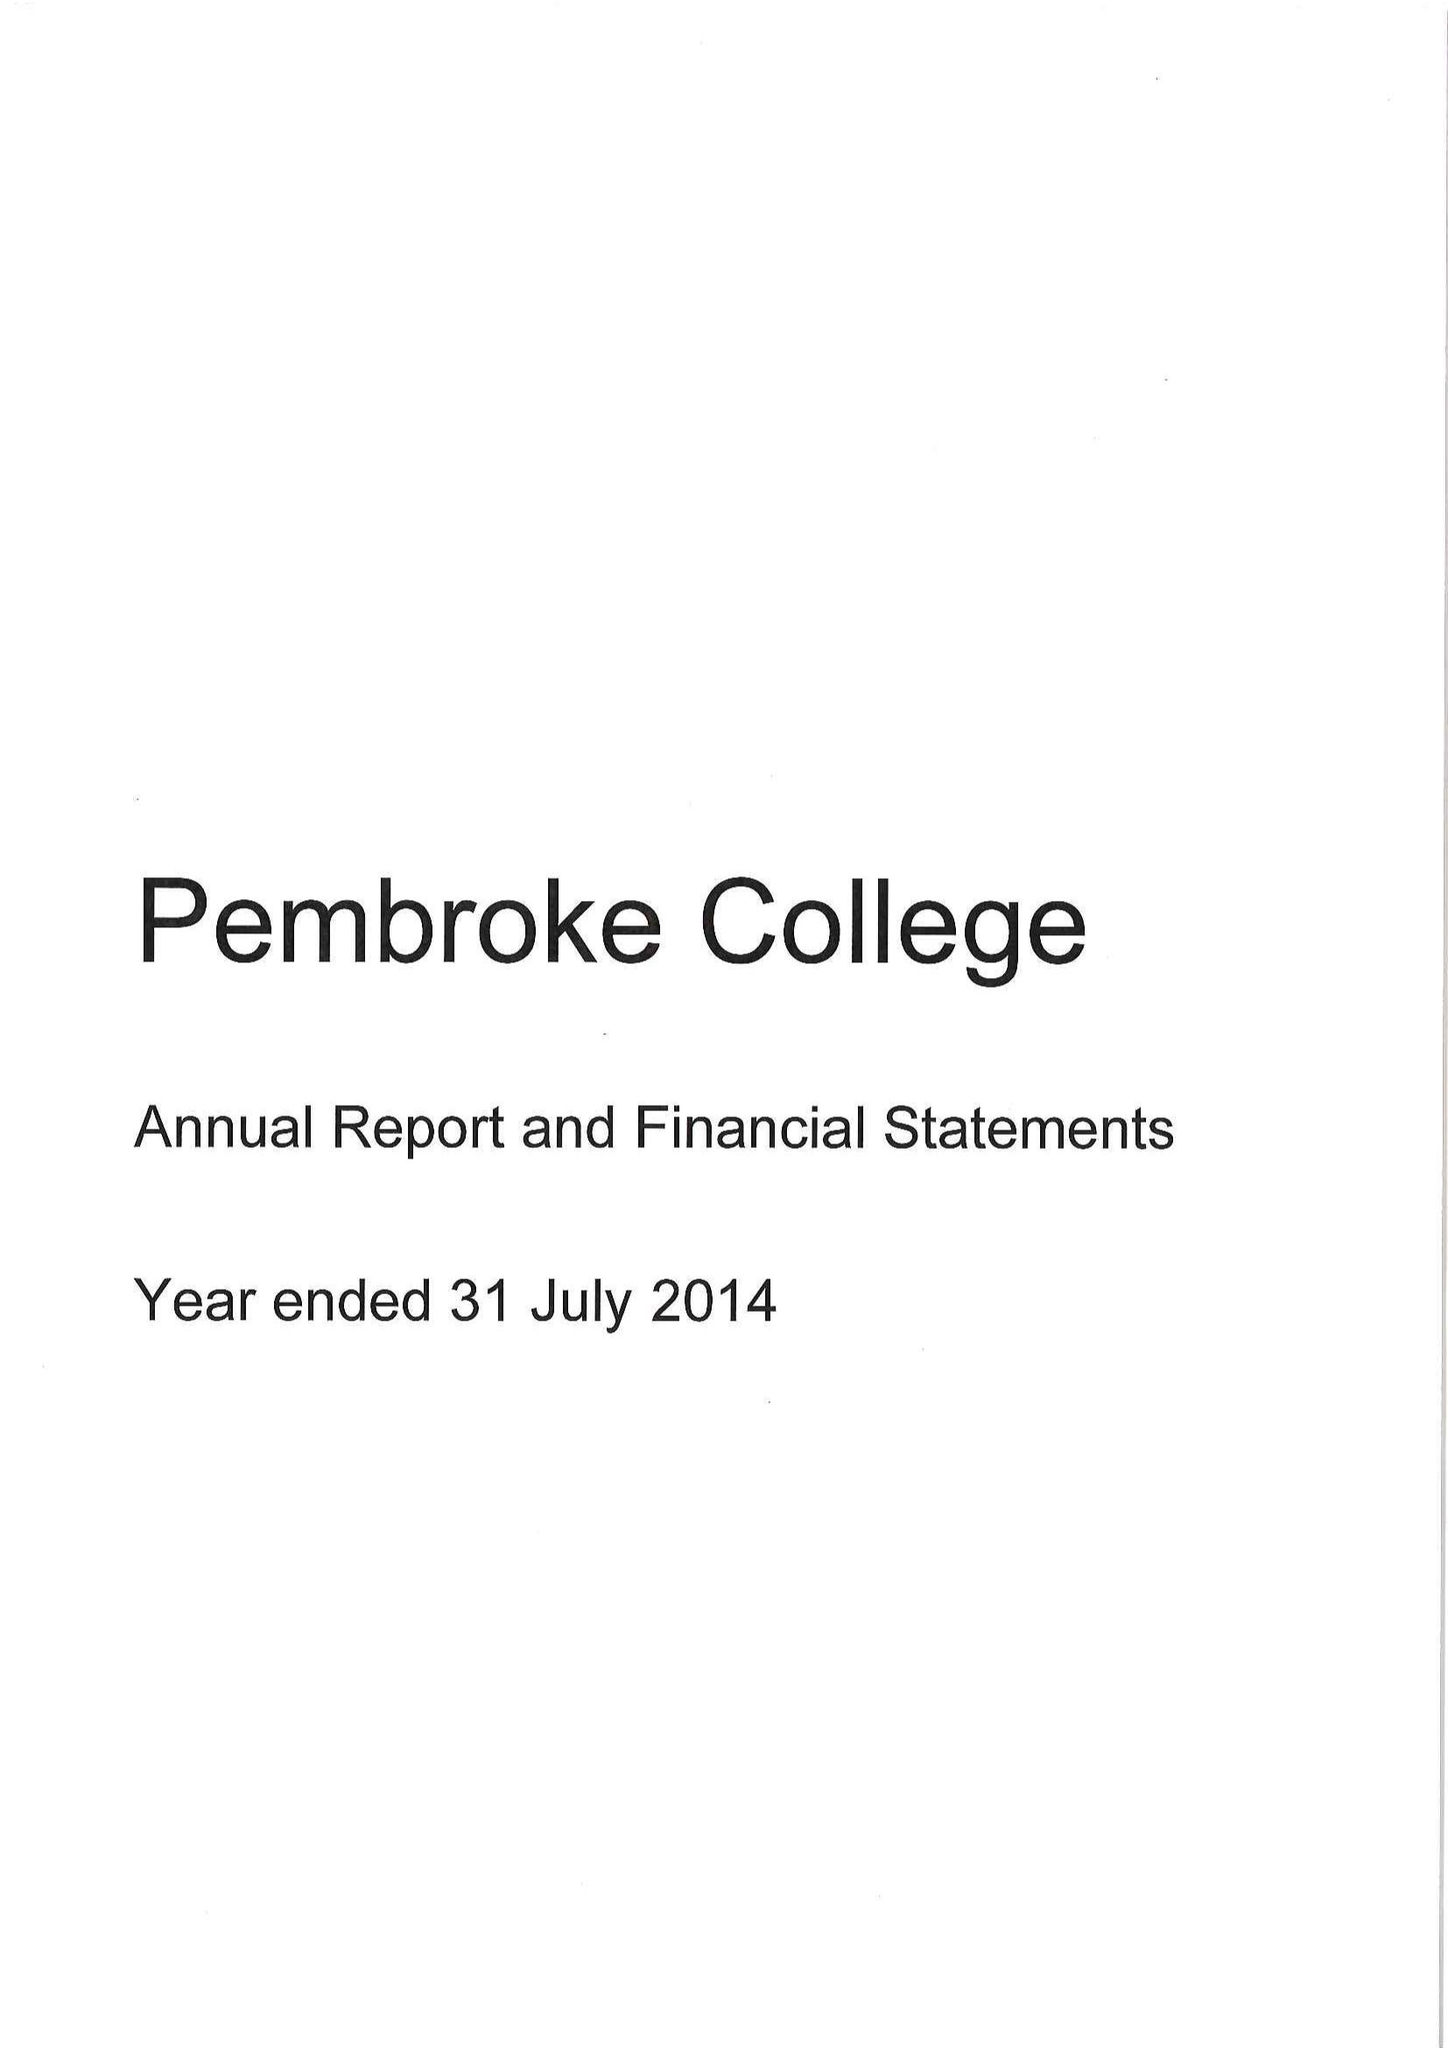What is the value for the spending_annually_in_british_pounds?
Answer the question using a single word or phrase. 10928000.00 